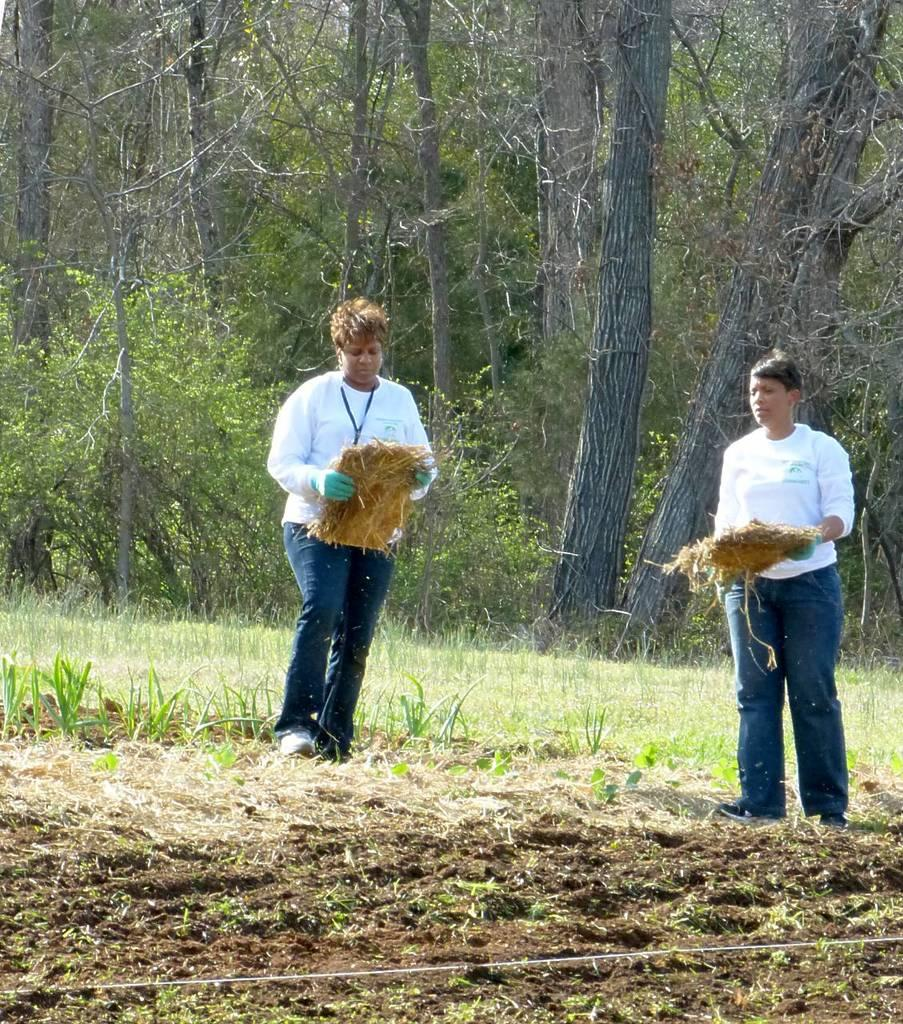How many people are in the image? There are two people in the image. What are the people doing in the image? The two people are standing on a grassy land and holding an object. What can be seen in the background of the image? There are trees in the background of the image. Is there a crook visible in the hands of the people in the image? No, there is no crook visible in the image; the people are holding an unspecified object. 